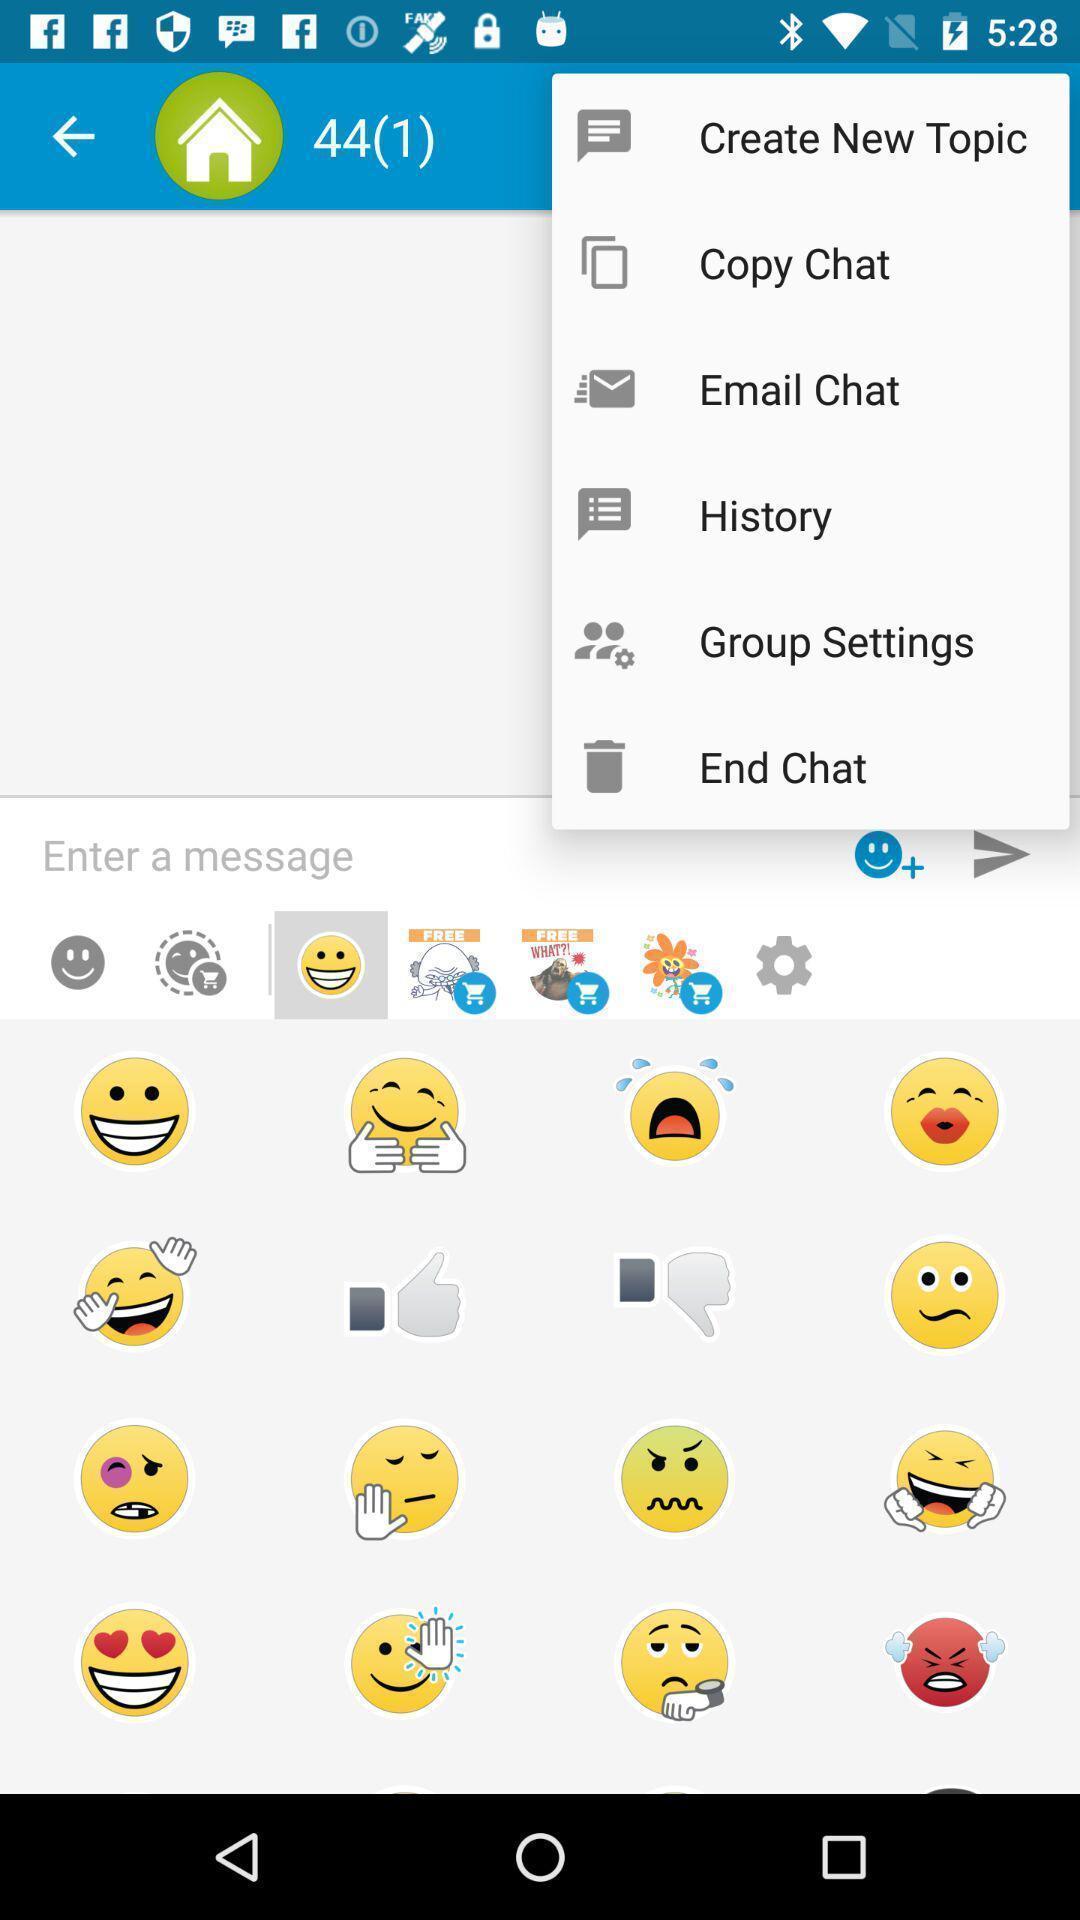Provide a detailed account of this screenshot. Search bar of chat page with different emojis. 